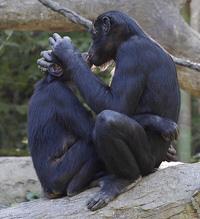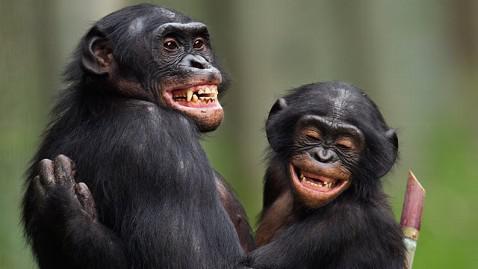The first image is the image on the left, the second image is the image on the right. Assess this claim about the two images: "The apes are hugging each other in both pictures.". Correct or not? Answer yes or no. Yes. The first image is the image on the left, the second image is the image on the right. Analyze the images presented: Is the assertion "chimps are hugging each other in both image pairs" valid? Answer yes or no. Yes. 